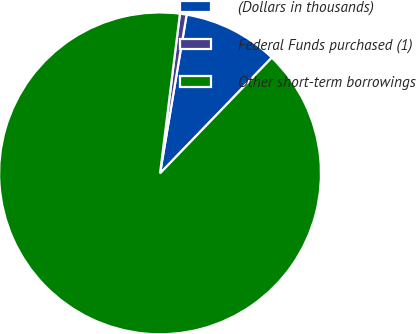Convert chart. <chart><loc_0><loc_0><loc_500><loc_500><pie_chart><fcel>(Dollars in thousands)<fcel>Federal Funds purchased (1)<fcel>Other short-term borrowings<nl><fcel>9.58%<fcel>0.67%<fcel>89.75%<nl></chart> 